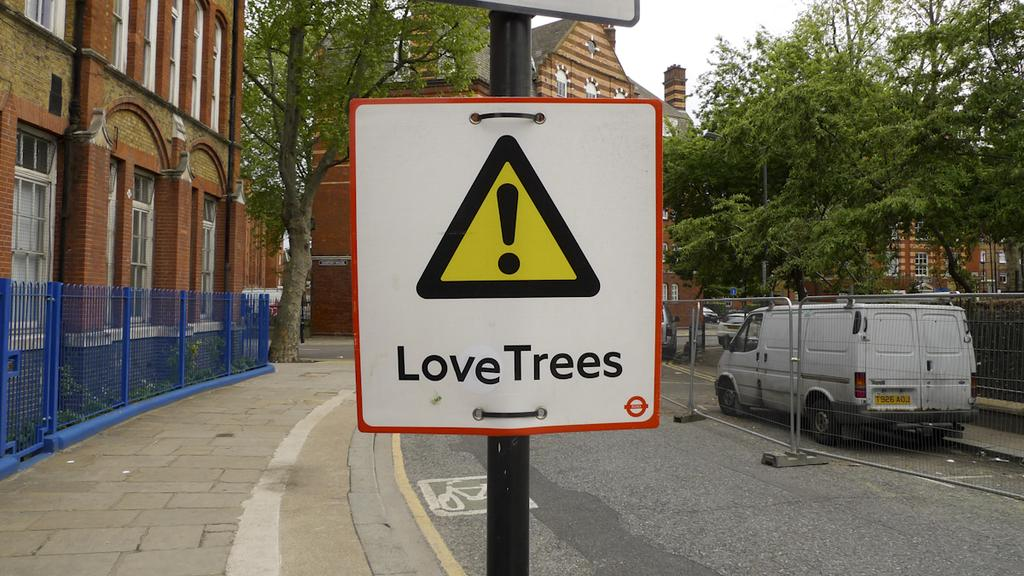<image>
Write a terse but informative summary of the picture. A white and red bordered sign reads Love trees on it. 